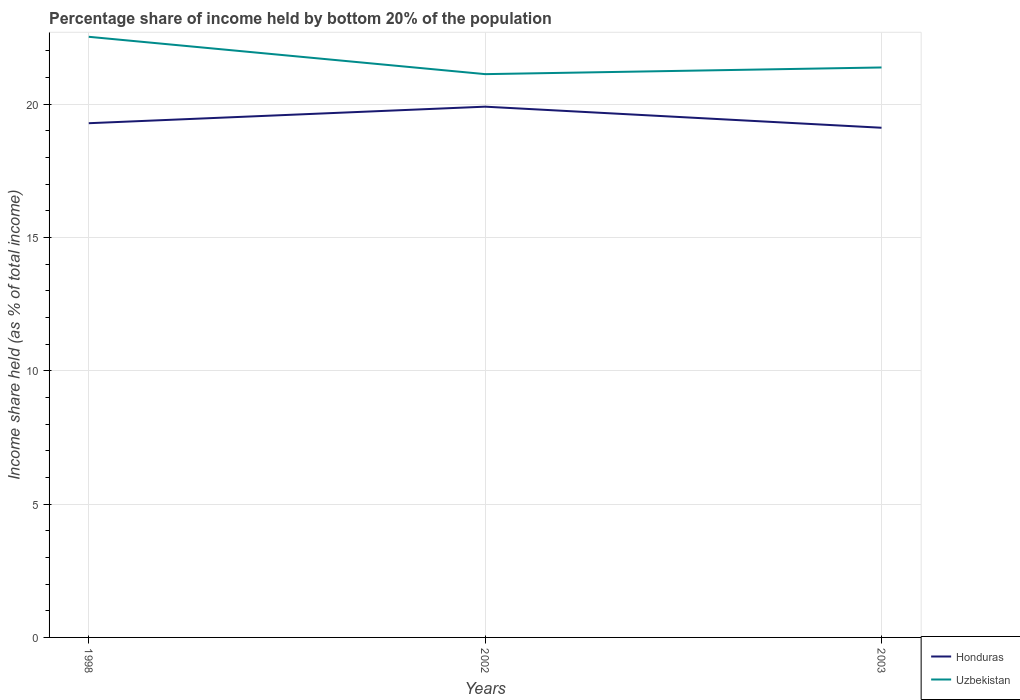How many different coloured lines are there?
Your response must be concise. 2. Does the line corresponding to Uzbekistan intersect with the line corresponding to Honduras?
Offer a very short reply. No. Across all years, what is the maximum share of income held by bottom 20% of the population in Honduras?
Offer a terse response. 19.11. What is the total share of income held by bottom 20% of the population in Uzbekistan in the graph?
Offer a terse response. 1.15. What is the difference between the highest and the second highest share of income held by bottom 20% of the population in Honduras?
Your answer should be very brief. 0.79. How many lines are there?
Your answer should be very brief. 2. How many years are there in the graph?
Your answer should be compact. 3. Does the graph contain grids?
Give a very brief answer. Yes. Where does the legend appear in the graph?
Give a very brief answer. Bottom right. How many legend labels are there?
Your answer should be very brief. 2. How are the legend labels stacked?
Offer a very short reply. Vertical. What is the title of the graph?
Offer a very short reply. Percentage share of income held by bottom 20% of the population. Does "Papua New Guinea" appear as one of the legend labels in the graph?
Provide a succinct answer. No. What is the label or title of the Y-axis?
Offer a terse response. Income share held (as % of total income). What is the Income share held (as % of total income) in Honduras in 1998?
Your response must be concise. 19.28. What is the Income share held (as % of total income) of Uzbekistan in 1998?
Your answer should be compact. 22.52. What is the Income share held (as % of total income) of Uzbekistan in 2002?
Your response must be concise. 21.12. What is the Income share held (as % of total income) of Honduras in 2003?
Provide a succinct answer. 19.11. What is the Income share held (as % of total income) in Uzbekistan in 2003?
Your response must be concise. 21.37. Across all years, what is the maximum Income share held (as % of total income) of Honduras?
Ensure brevity in your answer.  19.9. Across all years, what is the maximum Income share held (as % of total income) of Uzbekistan?
Your answer should be compact. 22.52. Across all years, what is the minimum Income share held (as % of total income) of Honduras?
Offer a very short reply. 19.11. Across all years, what is the minimum Income share held (as % of total income) of Uzbekistan?
Make the answer very short. 21.12. What is the total Income share held (as % of total income) of Honduras in the graph?
Make the answer very short. 58.29. What is the total Income share held (as % of total income) in Uzbekistan in the graph?
Your answer should be compact. 65.01. What is the difference between the Income share held (as % of total income) in Honduras in 1998 and that in 2002?
Keep it short and to the point. -0.62. What is the difference between the Income share held (as % of total income) in Uzbekistan in 1998 and that in 2002?
Your answer should be very brief. 1.4. What is the difference between the Income share held (as % of total income) in Honduras in 1998 and that in 2003?
Provide a short and direct response. 0.17. What is the difference between the Income share held (as % of total income) of Uzbekistan in 1998 and that in 2003?
Your response must be concise. 1.15. What is the difference between the Income share held (as % of total income) of Honduras in 2002 and that in 2003?
Ensure brevity in your answer.  0.79. What is the difference between the Income share held (as % of total income) in Honduras in 1998 and the Income share held (as % of total income) in Uzbekistan in 2002?
Provide a short and direct response. -1.84. What is the difference between the Income share held (as % of total income) in Honduras in 1998 and the Income share held (as % of total income) in Uzbekistan in 2003?
Give a very brief answer. -2.09. What is the difference between the Income share held (as % of total income) of Honduras in 2002 and the Income share held (as % of total income) of Uzbekistan in 2003?
Your response must be concise. -1.47. What is the average Income share held (as % of total income) of Honduras per year?
Make the answer very short. 19.43. What is the average Income share held (as % of total income) of Uzbekistan per year?
Provide a succinct answer. 21.67. In the year 1998, what is the difference between the Income share held (as % of total income) of Honduras and Income share held (as % of total income) of Uzbekistan?
Offer a terse response. -3.24. In the year 2002, what is the difference between the Income share held (as % of total income) in Honduras and Income share held (as % of total income) in Uzbekistan?
Your answer should be compact. -1.22. In the year 2003, what is the difference between the Income share held (as % of total income) of Honduras and Income share held (as % of total income) of Uzbekistan?
Offer a very short reply. -2.26. What is the ratio of the Income share held (as % of total income) of Honduras in 1998 to that in 2002?
Keep it short and to the point. 0.97. What is the ratio of the Income share held (as % of total income) in Uzbekistan in 1998 to that in 2002?
Your response must be concise. 1.07. What is the ratio of the Income share held (as % of total income) in Honduras in 1998 to that in 2003?
Ensure brevity in your answer.  1.01. What is the ratio of the Income share held (as % of total income) in Uzbekistan in 1998 to that in 2003?
Your answer should be compact. 1.05. What is the ratio of the Income share held (as % of total income) in Honduras in 2002 to that in 2003?
Your answer should be compact. 1.04. What is the ratio of the Income share held (as % of total income) of Uzbekistan in 2002 to that in 2003?
Your answer should be compact. 0.99. What is the difference between the highest and the second highest Income share held (as % of total income) of Honduras?
Your answer should be compact. 0.62. What is the difference between the highest and the second highest Income share held (as % of total income) of Uzbekistan?
Your answer should be compact. 1.15. What is the difference between the highest and the lowest Income share held (as % of total income) of Honduras?
Your answer should be very brief. 0.79. 